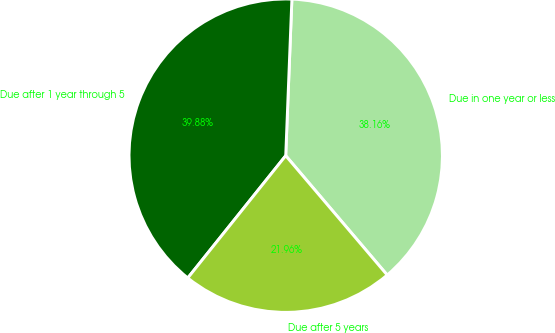<chart> <loc_0><loc_0><loc_500><loc_500><pie_chart><fcel>Due in one year or less<fcel>Due after 1 year through 5<fcel>Due after 5 years<nl><fcel>38.16%<fcel>39.88%<fcel>21.96%<nl></chart> 